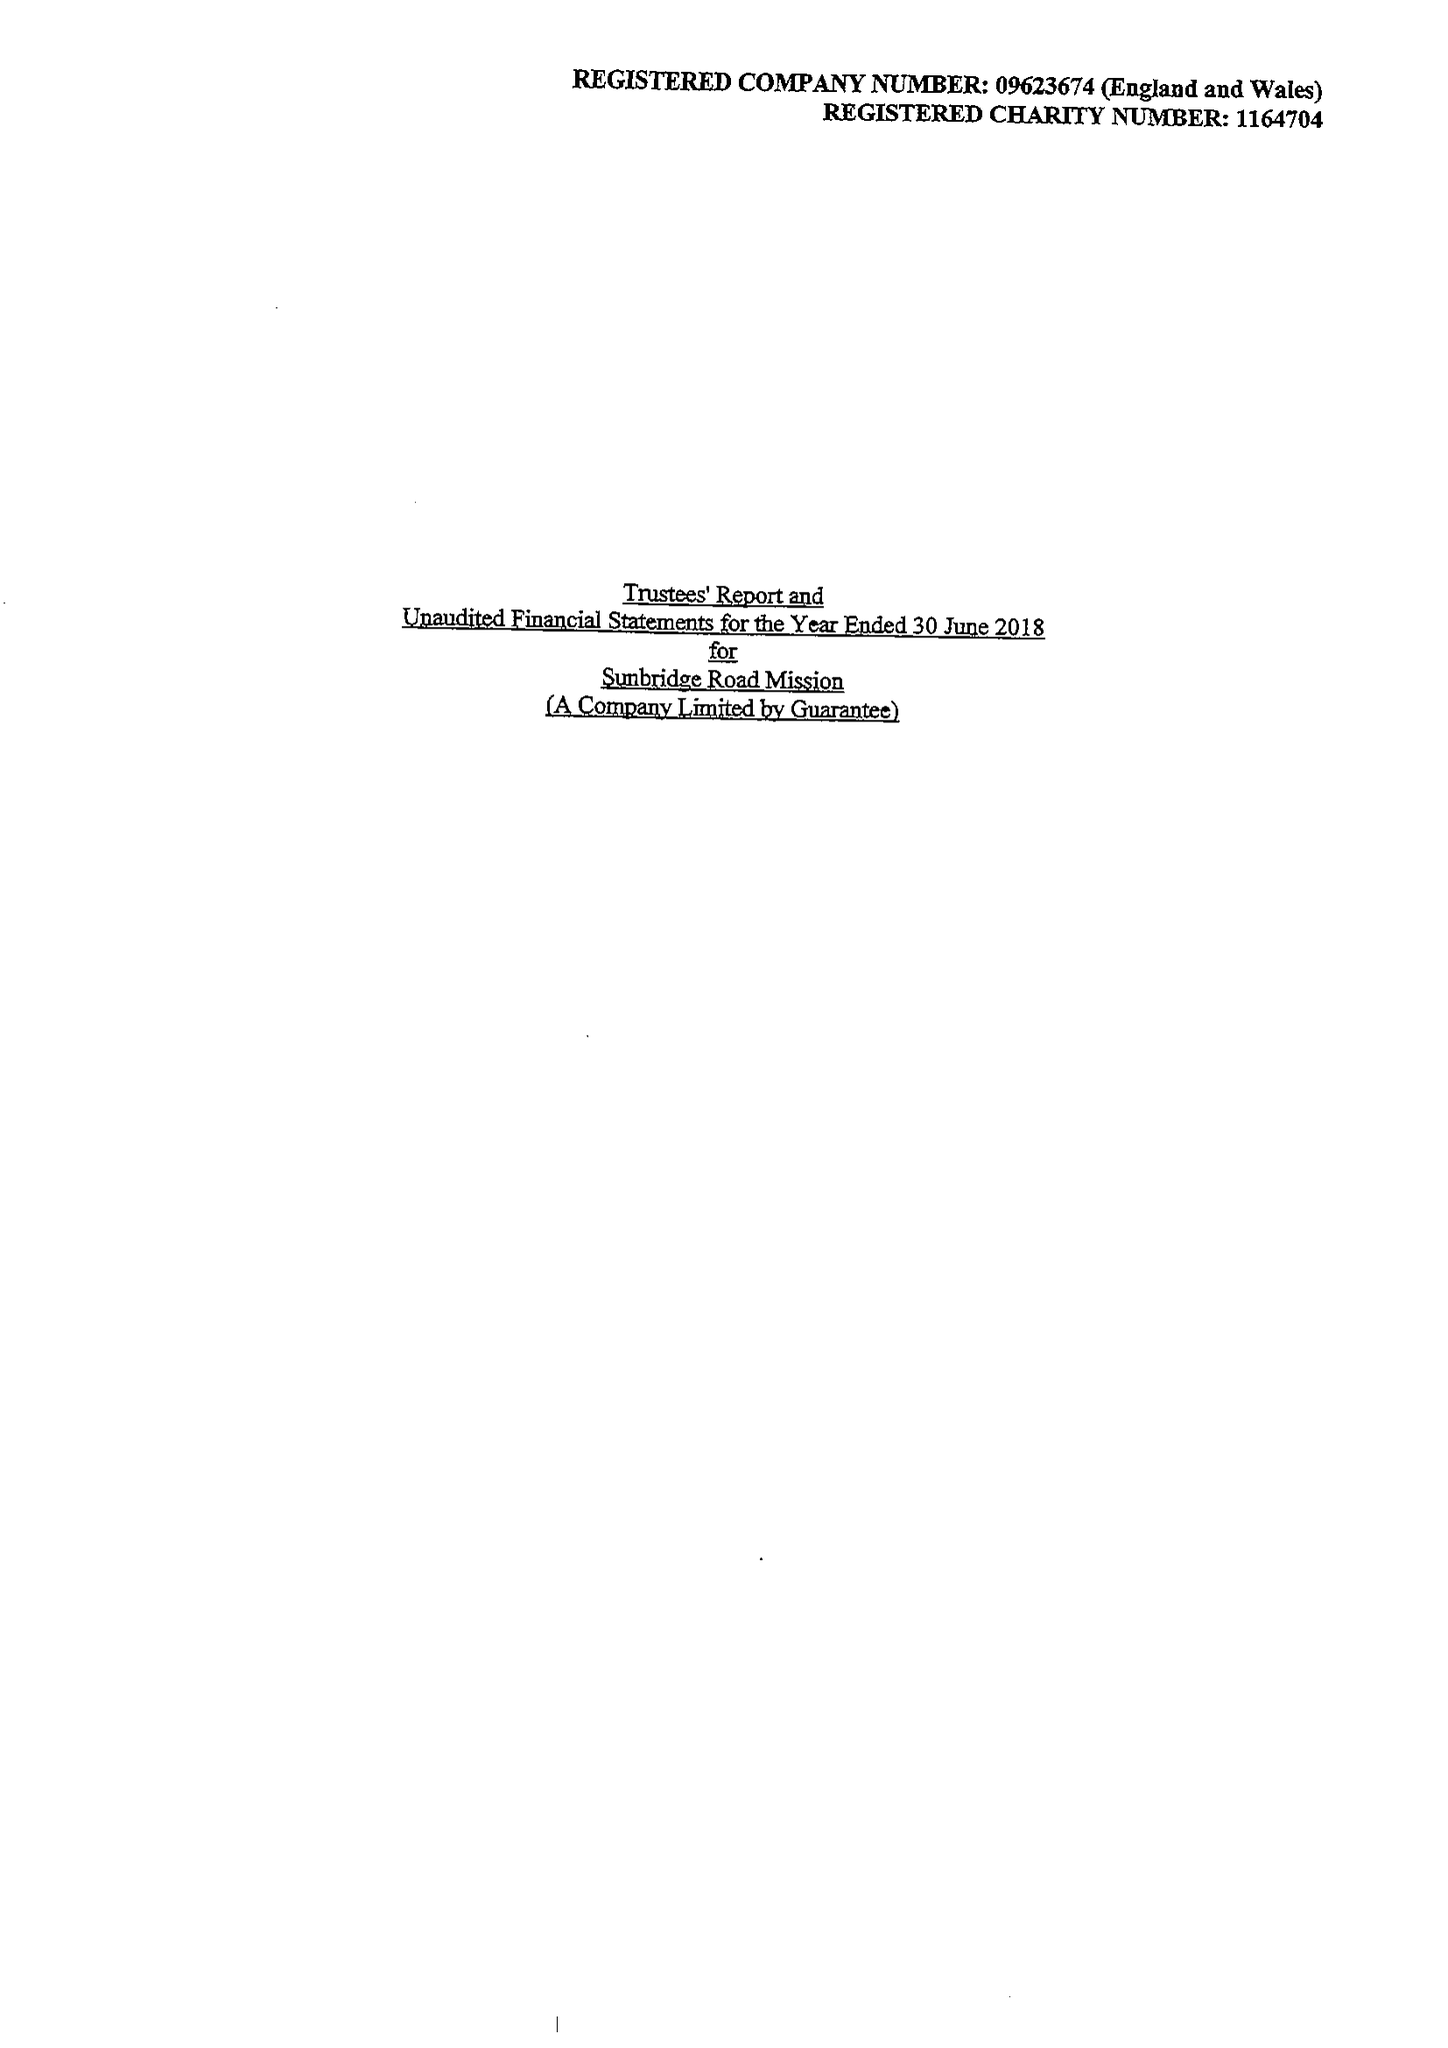What is the value for the spending_annually_in_british_pounds?
Answer the question using a single word or phrase. 184181.00 